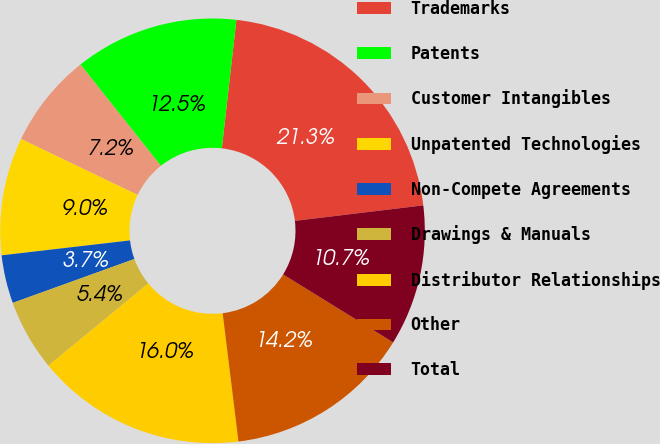<chart> <loc_0><loc_0><loc_500><loc_500><pie_chart><fcel>Trademarks<fcel>Patents<fcel>Customer Intangibles<fcel>Unpatented Technologies<fcel>Non-Compete Agreements<fcel>Drawings & Manuals<fcel>Distributor Relationships<fcel>Other<fcel>Total<nl><fcel>21.29%<fcel>12.48%<fcel>7.2%<fcel>8.96%<fcel>3.67%<fcel>5.43%<fcel>16.01%<fcel>14.24%<fcel>10.72%<nl></chart> 